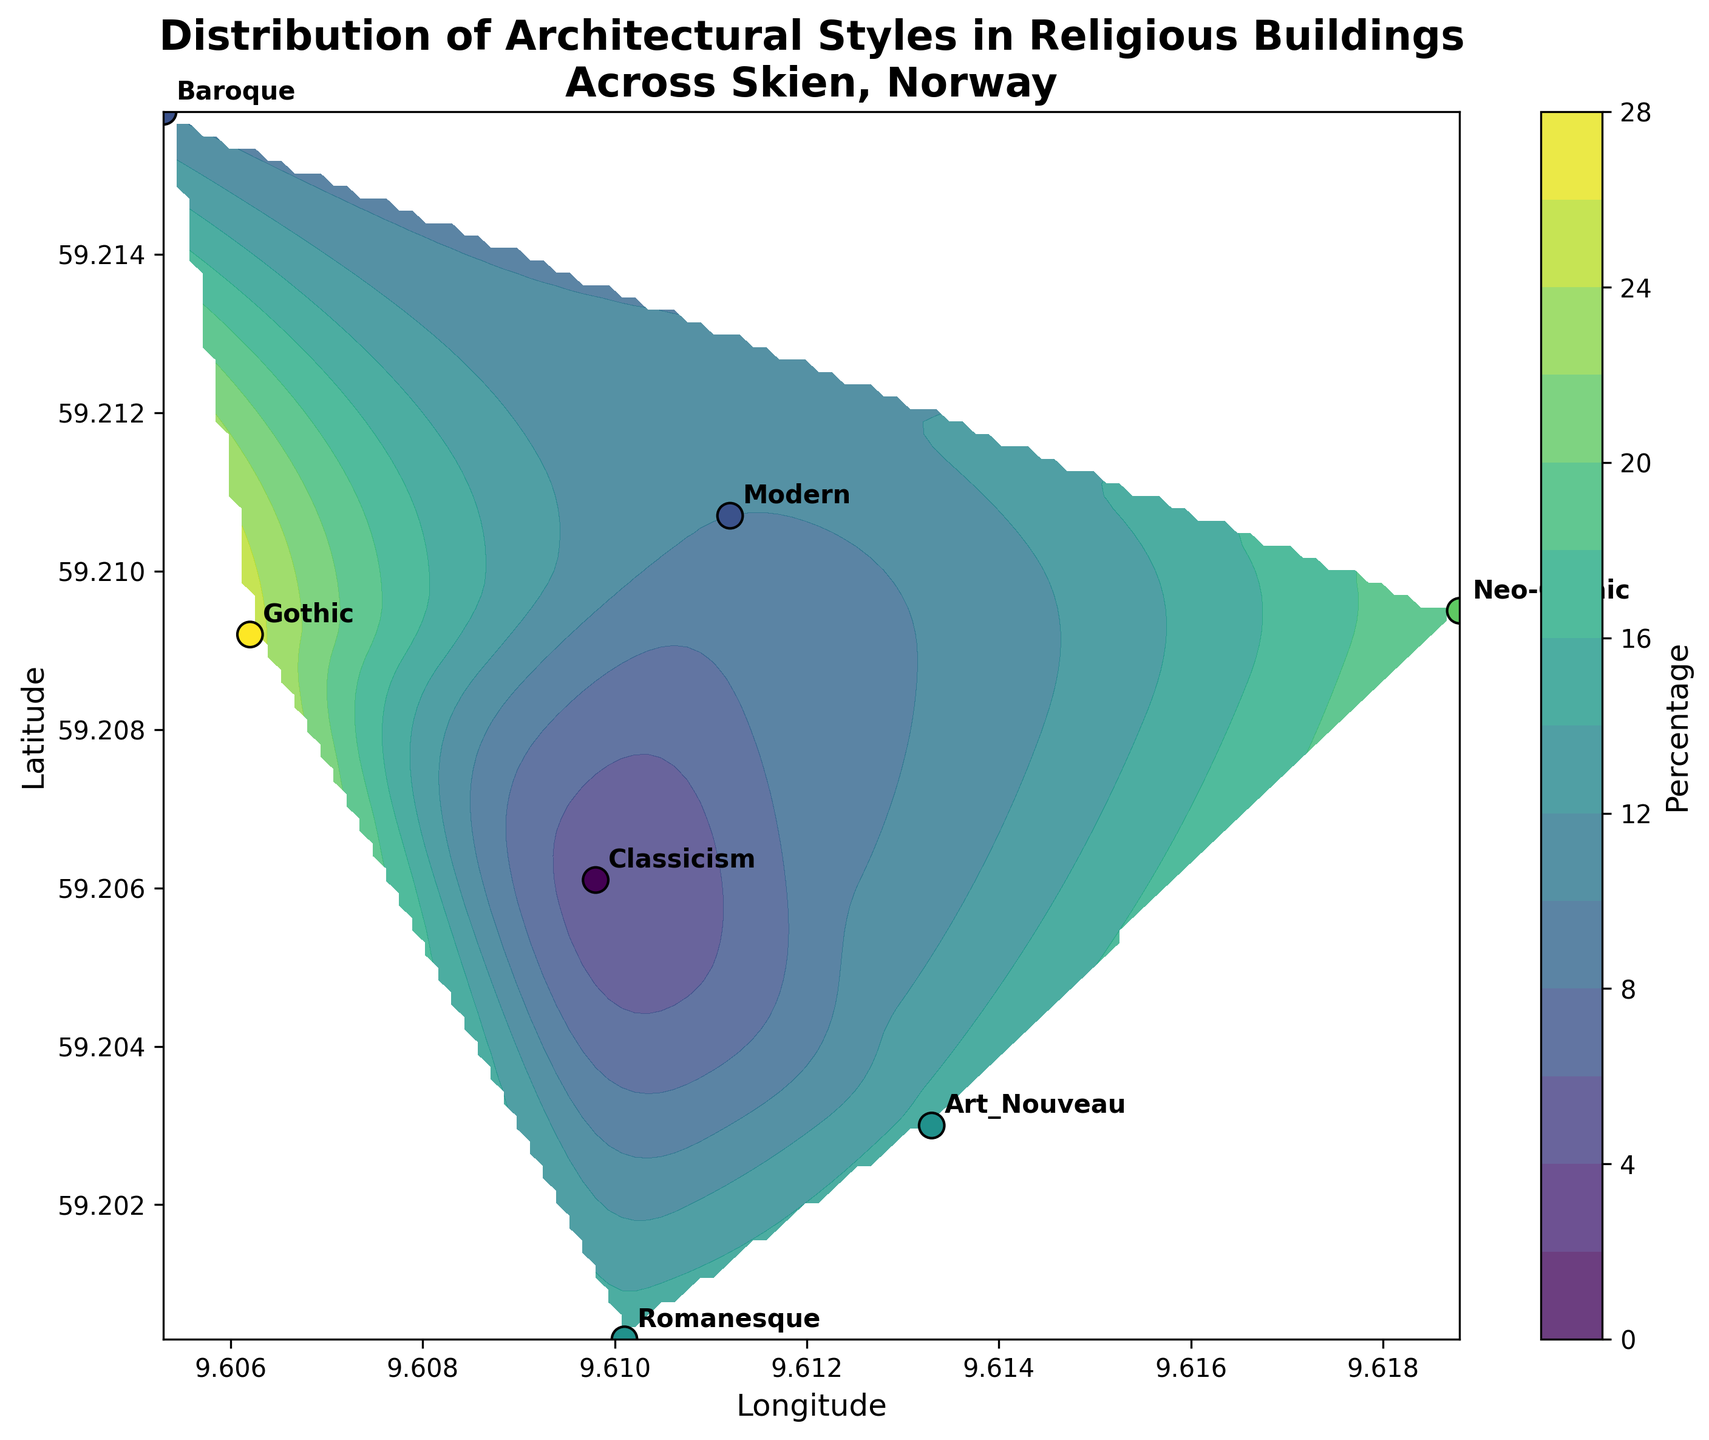What is the title of the figure? The title is visibly placed at the top of the figure. Observation indicates the complete sentence.
Answer: Distribution of Architectural Styles in Religious Buildings Across Skien, Norway How many architectural styles are indicated in the figure? By counting the unique labels or annotations next to the data points, we can determine the number of styles illustrated.
Answer: Seven Which architectural style has the highest percentage of presence? By examining the color intensity and annotation of each style, we identify the one with the highest percentage.
Answer: Gothic What are the longitude and latitude coordinates associated with the Art Nouveau style? By finding the label "Art_Nouveau" in the plot and reading the corresponding coordinates marked on the axis.
Answer: Longitude: 9.6133, Latitude: 59.2030 In which geographical direction (N, S, E, W) does the Neo-Gothic style lie compared to the Classicism style? By locating both "Neo-Gothic" and "Classicism" on the plot, we compare their positions relative to each other.
Answer: East What is the average percentage of presence of the Romanesque and Modern styles? We add the percentages for Romanesque (15%) and Modern (10%) and then divide by 2.
Answer: (15 + 10) / 2 = 12.5% Which architectural styles are found north of the Classicism style based on latitude coordinates? We observe the figure to identify styles with higher latitude values than 59.2061 (Classicism's latitude).
Answer: Gothic, Romanesque, Baroque, Neo-Gothic, Modern Between the Gothic and Baroque styles, which one has a lower percentage of presence? Comparing their annotated percentages, we identify the one with the smaller number.
Answer: Baroque (10%) Describe the contour color gradient representation and its significance. Observing the contour colors, we note that lighter shades represent higher percentages and darker shades represent lower percentages.
Answer: Lighter shades represent higher percentages 